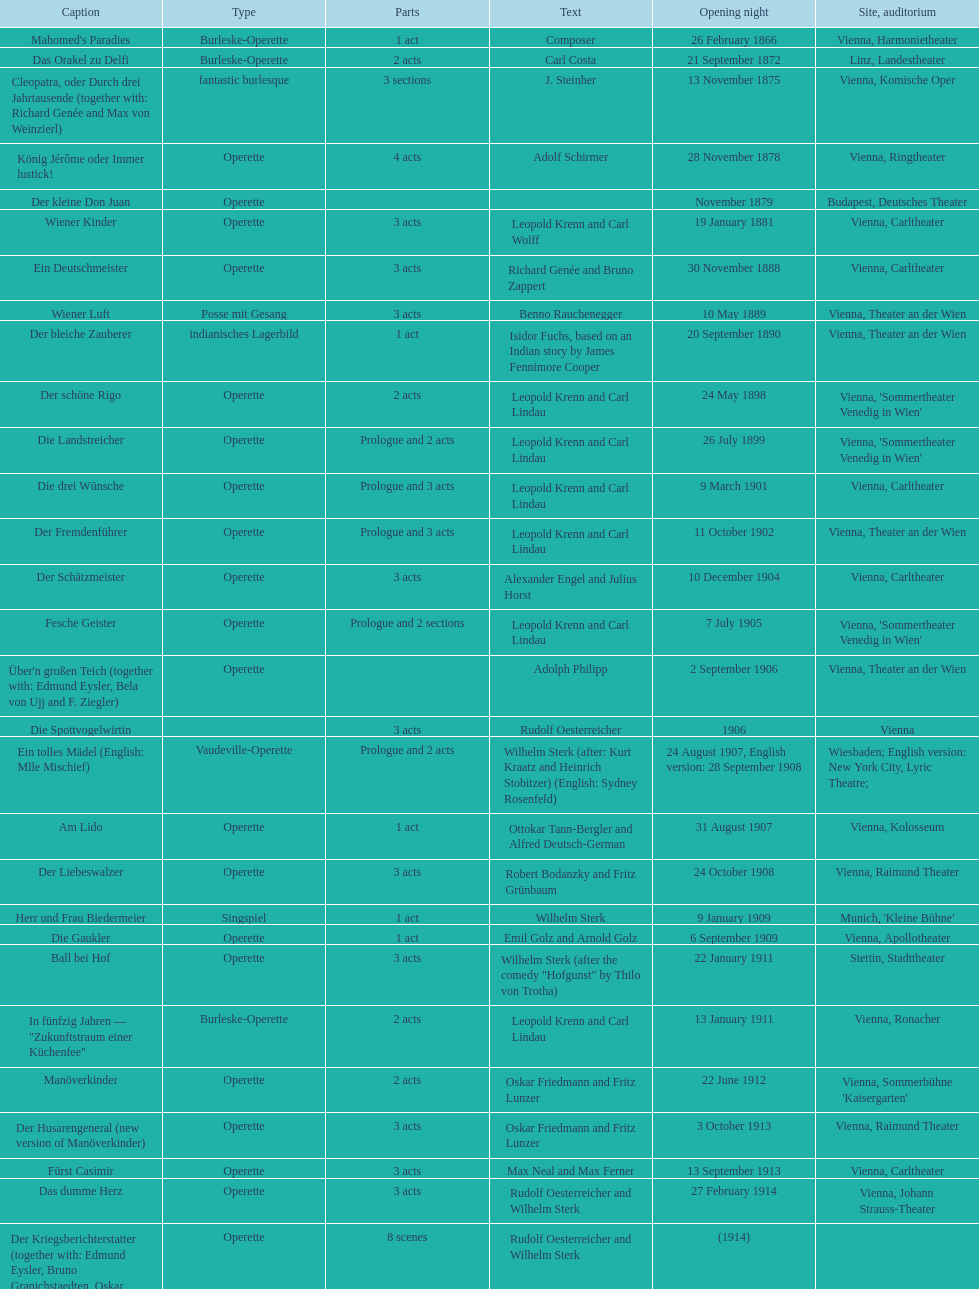Does der liebeswalzer or manöverkinder contain more acts? Der Liebeswalzer. Can you give me this table as a dict? {'header': ['Caption', 'Type', 'Parts', 'Text', 'Opening night', 'Site, auditorium'], 'rows': [["Mahomed's Paradies", 'Burleske-Operette', '1 act', 'Composer', '26 February 1866', 'Vienna, Harmonietheater'], ['Das Orakel zu Delfi', 'Burleske-Operette', '2 acts', 'Carl Costa', '21 September 1872', 'Linz, Landestheater'], ['Cleopatra, oder Durch drei Jahrtausende (together with: Richard Genée and Max von Weinzierl)', 'fantastic burlesque', '3 sections', 'J. Steinher', '13 November 1875', 'Vienna, Komische Oper'], ['König Jérôme oder Immer lustick!', 'Operette', '4 acts', 'Adolf Schirmer', '28 November 1878', 'Vienna, Ringtheater'], ['Der kleine Don Juan', 'Operette', '', '', 'November 1879', 'Budapest, Deutsches Theater'], ['Wiener Kinder', 'Operette', '3 acts', 'Leopold Krenn and Carl Wolff', '19 January 1881', 'Vienna, Carltheater'], ['Ein Deutschmeister', 'Operette', '3 acts', 'Richard Genée and Bruno Zappert', '30 November 1888', 'Vienna, Carltheater'], ['Wiener Luft', 'Posse mit Gesang', '3 acts', 'Benno Rauchenegger', '10 May 1889', 'Vienna, Theater an der Wien'], ['Der bleiche Zauberer', 'indianisches Lagerbild', '1 act', 'Isidor Fuchs, based on an Indian story by James Fennimore Cooper', '20 September 1890', 'Vienna, Theater an der Wien'], ['Der schöne Rigo', 'Operette', '2 acts', 'Leopold Krenn and Carl Lindau', '24 May 1898', "Vienna, 'Sommertheater Venedig in Wien'"], ['Die Landstreicher', 'Operette', 'Prologue and 2 acts', 'Leopold Krenn and Carl Lindau', '26 July 1899', "Vienna, 'Sommertheater Venedig in Wien'"], ['Die drei Wünsche', 'Operette', 'Prologue and 3 acts', 'Leopold Krenn and Carl Lindau', '9 March 1901', 'Vienna, Carltheater'], ['Der Fremdenführer', 'Operette', 'Prologue and 3 acts', 'Leopold Krenn and Carl Lindau', '11 October 1902', 'Vienna, Theater an der Wien'], ['Der Schätzmeister', 'Operette', '3 acts', 'Alexander Engel and Julius Horst', '10 December 1904', 'Vienna, Carltheater'], ['Fesche Geister', 'Operette', 'Prologue and 2 sections', 'Leopold Krenn and Carl Lindau', '7 July 1905', "Vienna, 'Sommertheater Venedig in Wien'"], ["Über'n großen Teich (together with: Edmund Eysler, Bela von Ujj and F. Ziegler)", 'Operette', '', 'Adolph Philipp', '2 September 1906', 'Vienna, Theater an der Wien'], ['Die Spottvogelwirtin', '', '3 acts', 'Rudolf Oesterreicher', '1906', 'Vienna'], ['Ein tolles Mädel (English: Mlle Mischief)', 'Vaudeville-Operette', 'Prologue and 2 acts', 'Wilhelm Sterk (after: Kurt Kraatz and Heinrich Stobitzer) (English: Sydney Rosenfeld)', '24 August 1907, English version: 28 September 1908', 'Wiesbaden; English version: New York City, Lyric Theatre;'], ['Am Lido', 'Operette', '1 act', 'Ottokar Tann-Bergler and Alfred Deutsch-German', '31 August 1907', 'Vienna, Kolosseum'], ['Der Liebeswalzer', 'Operette', '3 acts', 'Robert Bodanzky and Fritz Grünbaum', '24 October 1908', 'Vienna, Raimund Theater'], ['Herr und Frau Biedermeier', 'Singspiel', '1 act', 'Wilhelm Sterk', '9 January 1909', "Munich, 'Kleine Bühne'"], ['Die Gaukler', 'Operette', '1 act', 'Emil Golz and Arnold Golz', '6 September 1909', 'Vienna, Apollotheater'], ['Ball bei Hof', 'Operette', '3 acts', 'Wilhelm Sterk (after the comedy "Hofgunst" by Thilo von Trotha)', '22 January 1911', 'Stettin, Stadttheater'], ['In fünfzig Jahren — "Zukunftstraum einer Küchenfee"', 'Burleske-Operette', '2 acts', 'Leopold Krenn and Carl Lindau', '13 January 1911', 'Vienna, Ronacher'], ['Manöverkinder', 'Operette', '2 acts', 'Oskar Friedmann and Fritz Lunzer', '22 June 1912', "Vienna, Sommerbühne 'Kaisergarten'"], ['Der Husarengeneral (new version of Manöverkinder)', 'Operette', '3 acts', 'Oskar Friedmann and Fritz Lunzer', '3 October 1913', 'Vienna, Raimund Theater'], ['Fürst Casimir', 'Operette', '3 acts', 'Max Neal and Max Ferner', '13 September 1913', 'Vienna, Carltheater'], ['Das dumme Herz', 'Operette', '3 acts', 'Rudolf Oesterreicher and Wilhelm Sterk', '27 February 1914', 'Vienna, Johann Strauss-Theater'], ['Der Kriegsberichterstatter (together with: Edmund Eysler, Bruno Granichstaedten, Oskar Nedbal, Charles Weinberger)', 'Operette', '8 scenes', 'Rudolf Oesterreicher and Wilhelm Sterk', '(1914)', ''], ['Im siebenten Himmel', 'Operette', '3 acts', 'Max Neal and Max Ferner', '26 February 1916', 'Munich, Theater am Gärtnerplatz'], ['Deutschmeisterkapelle', 'Operette', '', 'Hubert Marischka and Rudolf Oesterreicher', '30 May 1958', 'Vienna, Raimund Theater'], ['Die verliebte Eskadron', 'Operette', '3 acts', 'Wilhelm Sterk (after B. Buchbinder)', '11 July 1930', 'Vienna, Johann-Strauß-Theater']]} 